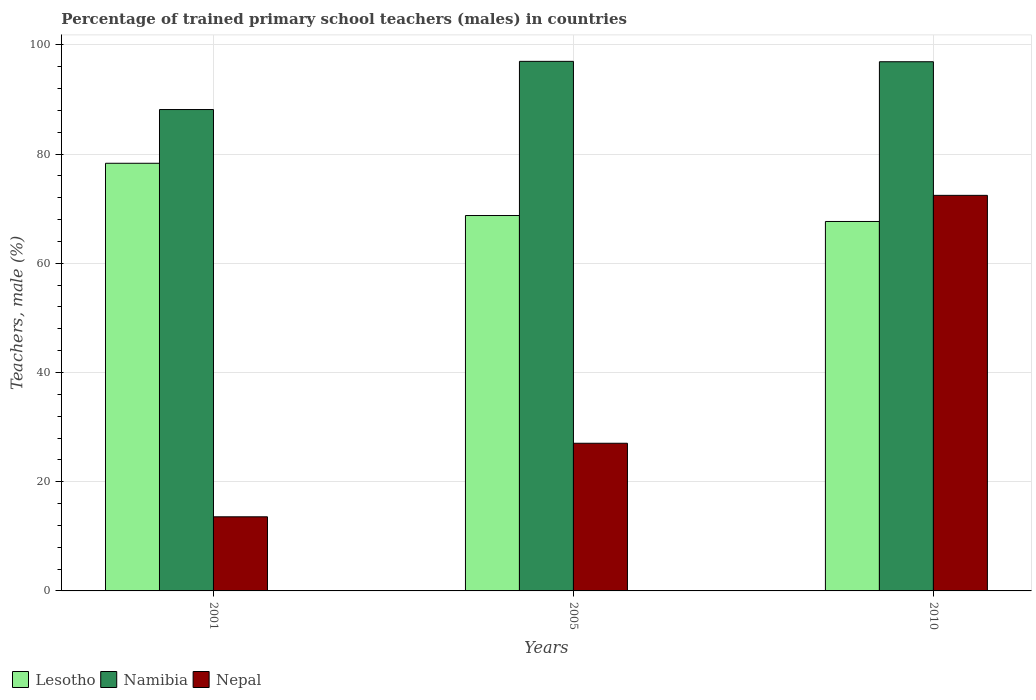How many different coloured bars are there?
Your answer should be very brief. 3. Are the number of bars per tick equal to the number of legend labels?
Your answer should be compact. Yes. How many bars are there on the 1st tick from the left?
Provide a succinct answer. 3. How many bars are there on the 1st tick from the right?
Offer a very short reply. 3. What is the label of the 2nd group of bars from the left?
Your answer should be compact. 2005. What is the percentage of trained primary school teachers (males) in Lesotho in 2010?
Your answer should be compact. 67.66. Across all years, what is the maximum percentage of trained primary school teachers (males) in Namibia?
Offer a terse response. 96.99. Across all years, what is the minimum percentage of trained primary school teachers (males) in Nepal?
Your answer should be compact. 13.57. In which year was the percentage of trained primary school teachers (males) in Nepal maximum?
Your response must be concise. 2010. In which year was the percentage of trained primary school teachers (males) in Lesotho minimum?
Offer a terse response. 2010. What is the total percentage of trained primary school teachers (males) in Namibia in the graph?
Provide a short and direct response. 282.07. What is the difference between the percentage of trained primary school teachers (males) in Lesotho in 2001 and that in 2005?
Your answer should be compact. 9.57. What is the difference between the percentage of trained primary school teachers (males) in Lesotho in 2005 and the percentage of trained primary school teachers (males) in Namibia in 2001?
Give a very brief answer. -19.41. What is the average percentage of trained primary school teachers (males) in Lesotho per year?
Your response must be concise. 71.58. In the year 2001, what is the difference between the percentage of trained primary school teachers (males) in Nepal and percentage of trained primary school teachers (males) in Lesotho?
Make the answer very short. -64.75. What is the ratio of the percentage of trained primary school teachers (males) in Lesotho in 2001 to that in 2010?
Your answer should be very brief. 1.16. Is the percentage of trained primary school teachers (males) in Namibia in 2001 less than that in 2010?
Your answer should be very brief. Yes. Is the difference between the percentage of trained primary school teachers (males) in Nepal in 2001 and 2010 greater than the difference between the percentage of trained primary school teachers (males) in Lesotho in 2001 and 2010?
Provide a succinct answer. No. What is the difference between the highest and the second highest percentage of trained primary school teachers (males) in Lesotho?
Offer a terse response. 9.57. What is the difference between the highest and the lowest percentage of trained primary school teachers (males) in Nepal?
Your answer should be very brief. 58.87. Is the sum of the percentage of trained primary school teachers (males) in Lesotho in 2001 and 2005 greater than the maximum percentage of trained primary school teachers (males) in Namibia across all years?
Give a very brief answer. Yes. What does the 2nd bar from the left in 2005 represents?
Make the answer very short. Namibia. What does the 1st bar from the right in 2001 represents?
Make the answer very short. Nepal. Is it the case that in every year, the sum of the percentage of trained primary school teachers (males) in Nepal and percentage of trained primary school teachers (males) in Lesotho is greater than the percentage of trained primary school teachers (males) in Namibia?
Your answer should be very brief. No. How many bars are there?
Offer a terse response. 9. How many years are there in the graph?
Provide a short and direct response. 3. What is the difference between two consecutive major ticks on the Y-axis?
Provide a succinct answer. 20. Does the graph contain any zero values?
Make the answer very short. No. Where does the legend appear in the graph?
Offer a very short reply. Bottom left. How many legend labels are there?
Your answer should be compact. 3. How are the legend labels stacked?
Provide a short and direct response. Horizontal. What is the title of the graph?
Ensure brevity in your answer.  Percentage of trained primary school teachers (males) in countries. Does "St. Lucia" appear as one of the legend labels in the graph?
Give a very brief answer. No. What is the label or title of the Y-axis?
Your answer should be very brief. Teachers, male (%). What is the Teachers, male (%) of Lesotho in 2001?
Your answer should be compact. 78.32. What is the Teachers, male (%) of Namibia in 2001?
Provide a succinct answer. 88.16. What is the Teachers, male (%) of Nepal in 2001?
Make the answer very short. 13.57. What is the Teachers, male (%) of Lesotho in 2005?
Offer a very short reply. 68.75. What is the Teachers, male (%) of Namibia in 2005?
Ensure brevity in your answer.  96.99. What is the Teachers, male (%) of Nepal in 2005?
Keep it short and to the point. 27.04. What is the Teachers, male (%) in Lesotho in 2010?
Keep it short and to the point. 67.66. What is the Teachers, male (%) of Namibia in 2010?
Offer a very short reply. 96.92. What is the Teachers, male (%) in Nepal in 2010?
Give a very brief answer. 72.45. Across all years, what is the maximum Teachers, male (%) of Lesotho?
Offer a terse response. 78.32. Across all years, what is the maximum Teachers, male (%) in Namibia?
Provide a succinct answer. 96.99. Across all years, what is the maximum Teachers, male (%) of Nepal?
Your answer should be compact. 72.45. Across all years, what is the minimum Teachers, male (%) in Lesotho?
Provide a succinct answer. 67.66. Across all years, what is the minimum Teachers, male (%) in Namibia?
Your answer should be very brief. 88.16. Across all years, what is the minimum Teachers, male (%) in Nepal?
Offer a terse response. 13.57. What is the total Teachers, male (%) of Lesotho in the graph?
Ensure brevity in your answer.  214.74. What is the total Teachers, male (%) in Namibia in the graph?
Provide a short and direct response. 282.07. What is the total Teachers, male (%) of Nepal in the graph?
Ensure brevity in your answer.  113.06. What is the difference between the Teachers, male (%) in Lesotho in 2001 and that in 2005?
Make the answer very short. 9.57. What is the difference between the Teachers, male (%) of Namibia in 2001 and that in 2005?
Provide a succinct answer. -8.83. What is the difference between the Teachers, male (%) of Nepal in 2001 and that in 2005?
Offer a terse response. -13.47. What is the difference between the Teachers, male (%) in Lesotho in 2001 and that in 2010?
Your response must be concise. 10.66. What is the difference between the Teachers, male (%) of Namibia in 2001 and that in 2010?
Make the answer very short. -8.76. What is the difference between the Teachers, male (%) in Nepal in 2001 and that in 2010?
Keep it short and to the point. -58.87. What is the difference between the Teachers, male (%) of Lesotho in 2005 and that in 2010?
Offer a terse response. 1.09. What is the difference between the Teachers, male (%) of Namibia in 2005 and that in 2010?
Your answer should be very brief. 0.07. What is the difference between the Teachers, male (%) of Nepal in 2005 and that in 2010?
Your answer should be very brief. -45.4. What is the difference between the Teachers, male (%) in Lesotho in 2001 and the Teachers, male (%) in Namibia in 2005?
Your response must be concise. -18.67. What is the difference between the Teachers, male (%) of Lesotho in 2001 and the Teachers, male (%) of Nepal in 2005?
Offer a terse response. 51.28. What is the difference between the Teachers, male (%) of Namibia in 2001 and the Teachers, male (%) of Nepal in 2005?
Give a very brief answer. 61.12. What is the difference between the Teachers, male (%) of Lesotho in 2001 and the Teachers, male (%) of Namibia in 2010?
Keep it short and to the point. -18.6. What is the difference between the Teachers, male (%) in Lesotho in 2001 and the Teachers, male (%) in Nepal in 2010?
Ensure brevity in your answer.  5.87. What is the difference between the Teachers, male (%) in Namibia in 2001 and the Teachers, male (%) in Nepal in 2010?
Provide a succinct answer. 15.72. What is the difference between the Teachers, male (%) in Lesotho in 2005 and the Teachers, male (%) in Namibia in 2010?
Offer a terse response. -28.17. What is the difference between the Teachers, male (%) in Lesotho in 2005 and the Teachers, male (%) in Nepal in 2010?
Your answer should be very brief. -3.69. What is the difference between the Teachers, male (%) of Namibia in 2005 and the Teachers, male (%) of Nepal in 2010?
Offer a terse response. 24.54. What is the average Teachers, male (%) of Lesotho per year?
Your answer should be very brief. 71.58. What is the average Teachers, male (%) of Namibia per year?
Your answer should be compact. 94.02. What is the average Teachers, male (%) of Nepal per year?
Offer a terse response. 37.69. In the year 2001, what is the difference between the Teachers, male (%) in Lesotho and Teachers, male (%) in Namibia?
Provide a succinct answer. -9.84. In the year 2001, what is the difference between the Teachers, male (%) of Lesotho and Teachers, male (%) of Nepal?
Make the answer very short. 64.75. In the year 2001, what is the difference between the Teachers, male (%) in Namibia and Teachers, male (%) in Nepal?
Offer a very short reply. 74.59. In the year 2005, what is the difference between the Teachers, male (%) of Lesotho and Teachers, male (%) of Namibia?
Provide a succinct answer. -28.24. In the year 2005, what is the difference between the Teachers, male (%) in Lesotho and Teachers, male (%) in Nepal?
Offer a terse response. 41.71. In the year 2005, what is the difference between the Teachers, male (%) in Namibia and Teachers, male (%) in Nepal?
Provide a succinct answer. 69.94. In the year 2010, what is the difference between the Teachers, male (%) of Lesotho and Teachers, male (%) of Namibia?
Your answer should be compact. -29.26. In the year 2010, what is the difference between the Teachers, male (%) in Lesotho and Teachers, male (%) in Nepal?
Keep it short and to the point. -4.79. In the year 2010, what is the difference between the Teachers, male (%) of Namibia and Teachers, male (%) of Nepal?
Your response must be concise. 24.47. What is the ratio of the Teachers, male (%) of Lesotho in 2001 to that in 2005?
Provide a succinct answer. 1.14. What is the ratio of the Teachers, male (%) of Namibia in 2001 to that in 2005?
Keep it short and to the point. 0.91. What is the ratio of the Teachers, male (%) in Nepal in 2001 to that in 2005?
Your answer should be very brief. 0.5. What is the ratio of the Teachers, male (%) of Lesotho in 2001 to that in 2010?
Offer a terse response. 1.16. What is the ratio of the Teachers, male (%) in Namibia in 2001 to that in 2010?
Provide a succinct answer. 0.91. What is the ratio of the Teachers, male (%) in Nepal in 2001 to that in 2010?
Ensure brevity in your answer.  0.19. What is the ratio of the Teachers, male (%) of Lesotho in 2005 to that in 2010?
Your answer should be compact. 1.02. What is the ratio of the Teachers, male (%) of Namibia in 2005 to that in 2010?
Your answer should be compact. 1. What is the ratio of the Teachers, male (%) in Nepal in 2005 to that in 2010?
Offer a very short reply. 0.37. What is the difference between the highest and the second highest Teachers, male (%) in Lesotho?
Ensure brevity in your answer.  9.57. What is the difference between the highest and the second highest Teachers, male (%) of Namibia?
Your answer should be compact. 0.07. What is the difference between the highest and the second highest Teachers, male (%) in Nepal?
Make the answer very short. 45.4. What is the difference between the highest and the lowest Teachers, male (%) in Lesotho?
Provide a succinct answer. 10.66. What is the difference between the highest and the lowest Teachers, male (%) of Namibia?
Make the answer very short. 8.83. What is the difference between the highest and the lowest Teachers, male (%) in Nepal?
Give a very brief answer. 58.87. 